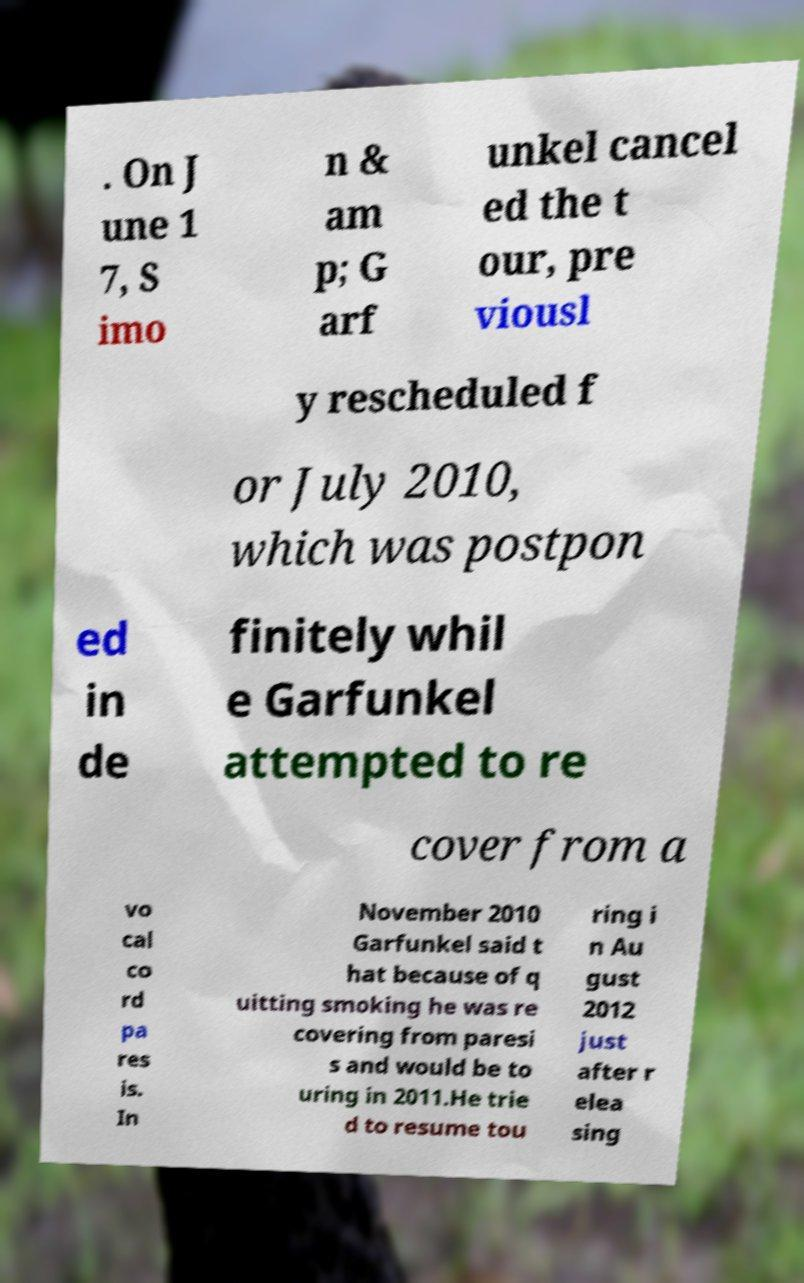There's text embedded in this image that I need extracted. Can you transcribe it verbatim? . On J une 1 7, S imo n & am p; G arf unkel cancel ed the t our, pre viousl y rescheduled f or July 2010, which was postpon ed in de finitely whil e Garfunkel attempted to re cover from a vo cal co rd pa res is. In November 2010 Garfunkel said t hat because of q uitting smoking he was re covering from paresi s and would be to uring in 2011.He trie d to resume tou ring i n Au gust 2012 just after r elea sing 